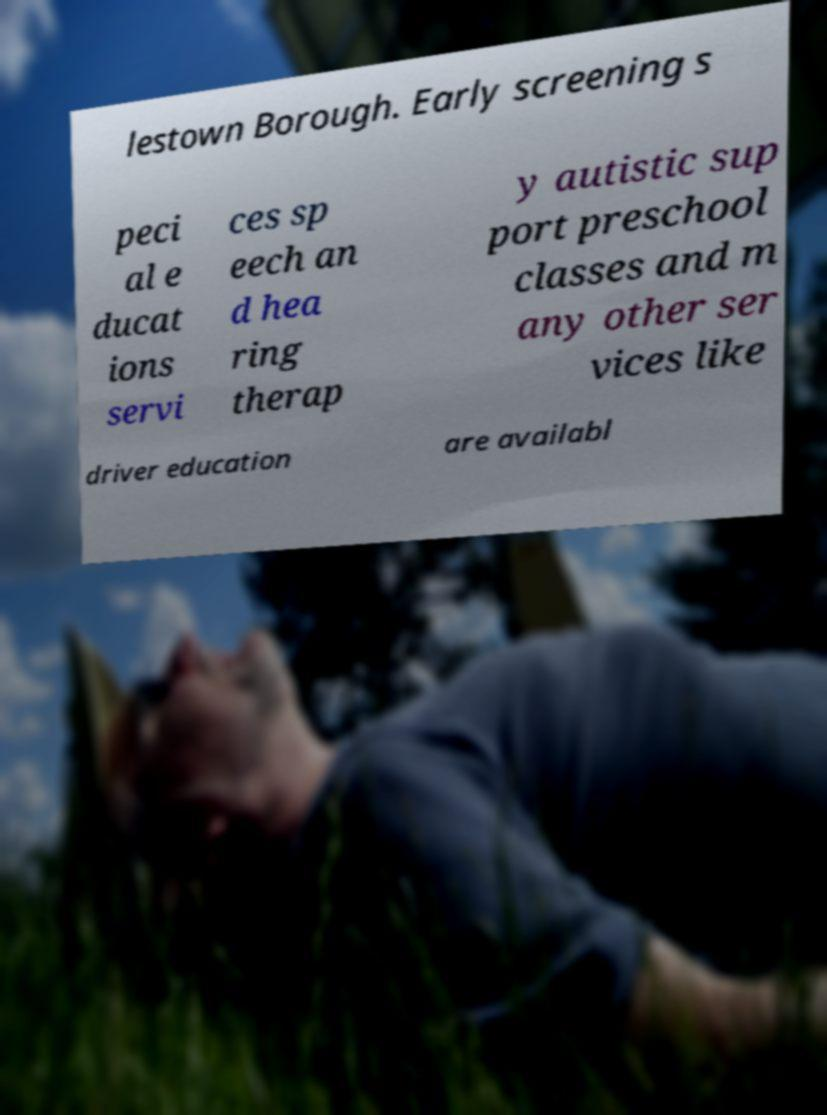Please identify and transcribe the text found in this image. lestown Borough. Early screening s peci al e ducat ions servi ces sp eech an d hea ring therap y autistic sup port preschool classes and m any other ser vices like driver education are availabl 